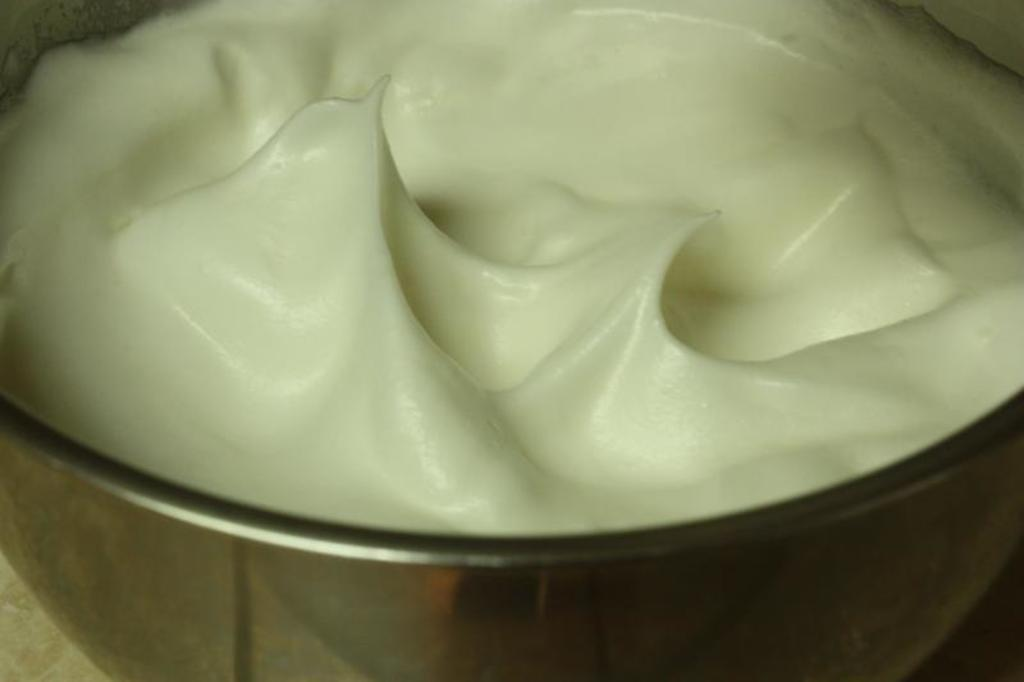What is in the bowl that is visible in the image? There is a bowl with cream in the image. What language is the cream speaking in the image? The cream is not speaking in the image, as it is an inanimate object and cannot communicate verbally. 